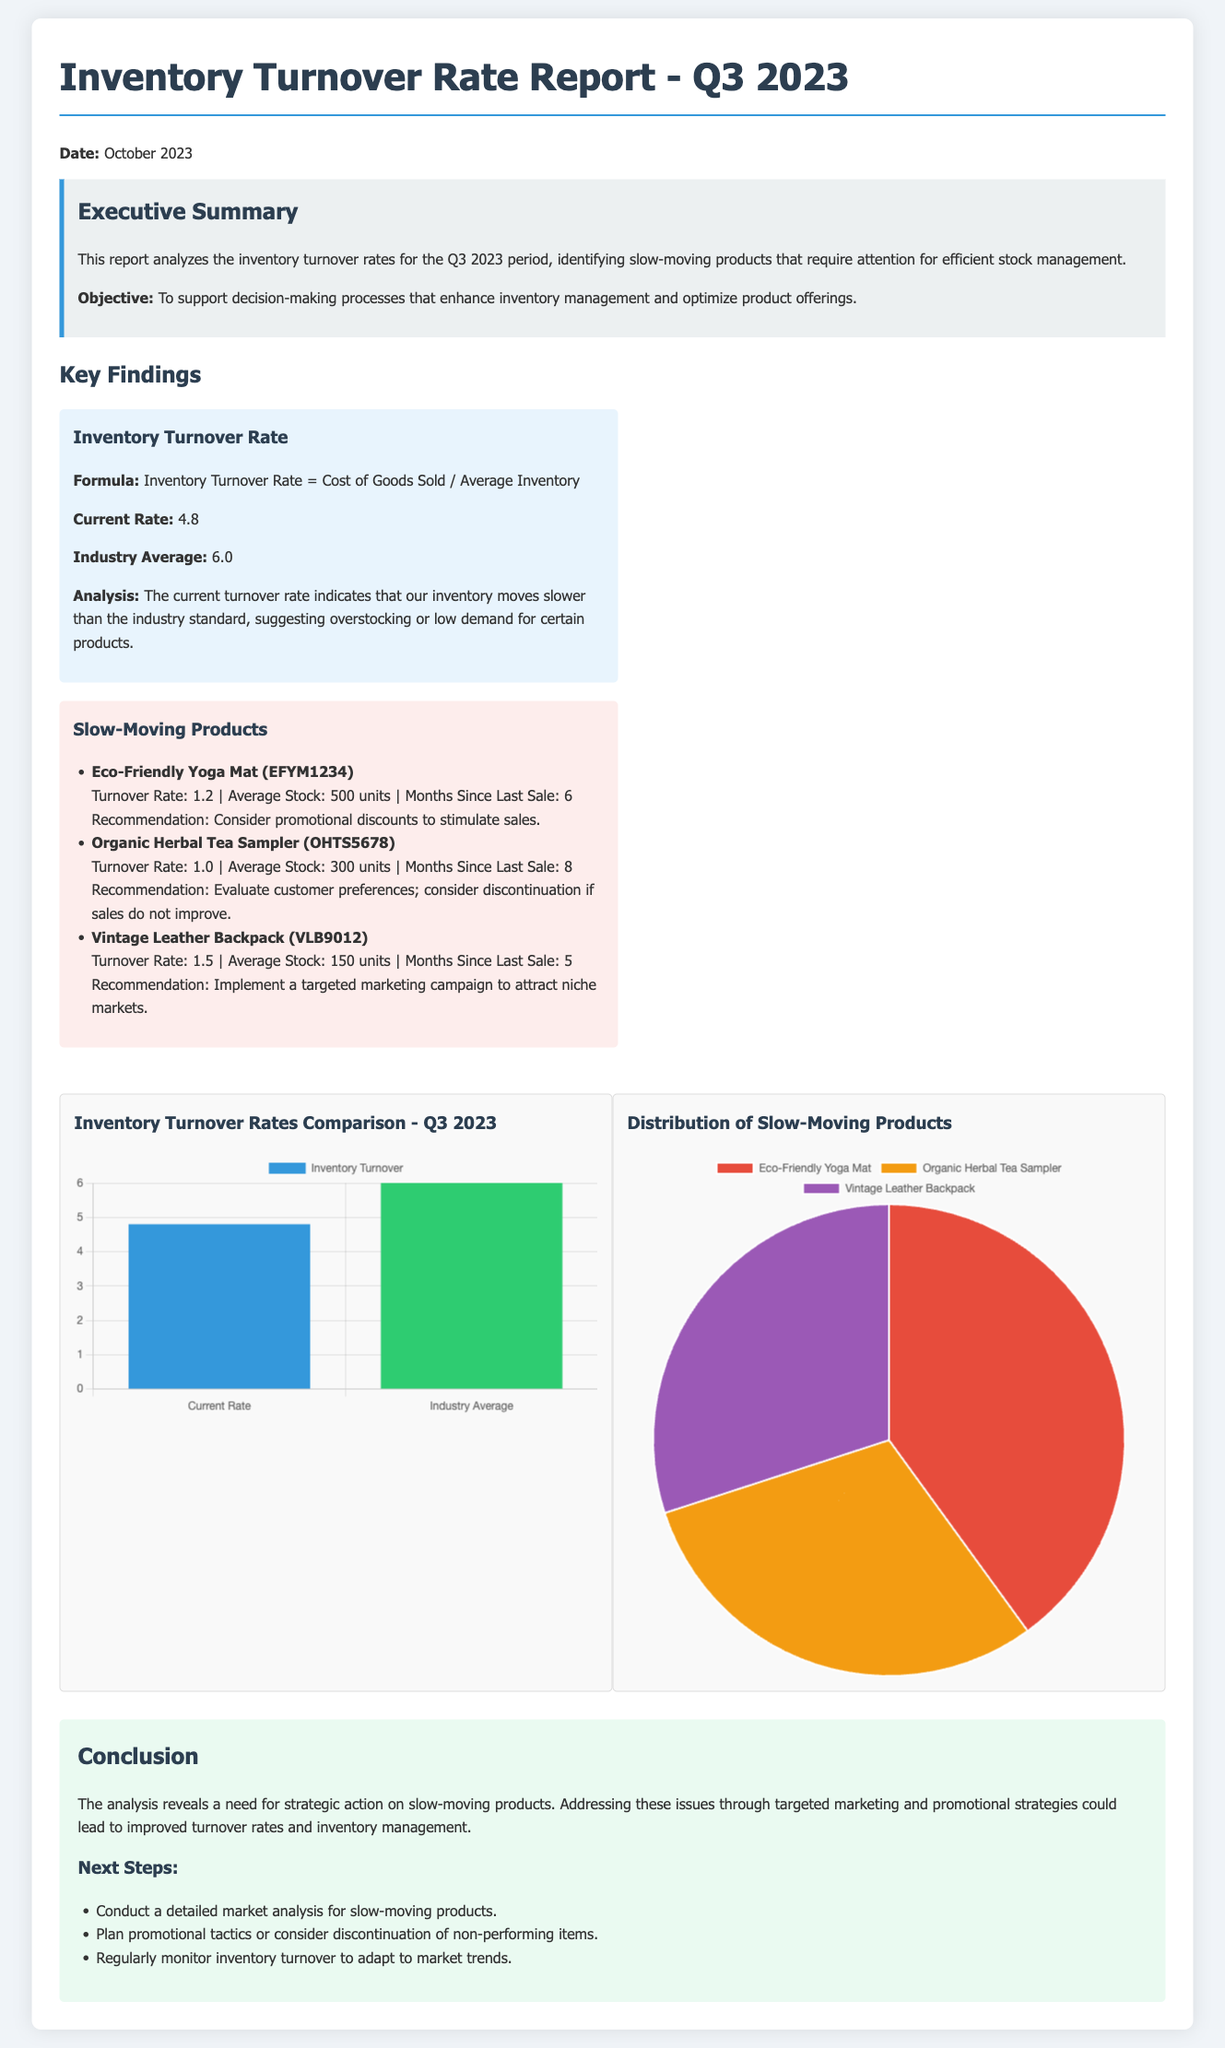What is the current inventory turnover rate? The current turnover rate is mentioned in the key findings section as part of the analysis.
Answer: 4.8 What is the industry average inventory turnover rate? The report states the industry average for comparison with the current rate in the key findings section.
Answer: 6.0 What is the turnover rate for the Eco-Friendly Yoga Mat? The slow-moving products section includes the turnover rate for this specific product.
Answer: 1.2 How many months has the Organic Herbal Tea Sampler been since its last sale? The detail for this product in the slow-moving section indicates how long it has remained unsold.
Answer: 8 What recommendation is given for the Vintage Leather Backpack? The recommended action for this product is listed in the slow-moving products section.
Answer: Implement a targeted marketing campaign to attract niche markets What type of visual aid is used to show the inventory turnover rates comparison? The document includes details about the type of chart used to illustrate the comparison of turnover rates.
Answer: Bar Chart What is the primary objective of this report? The executive summary outlines the main objective of the report, providing context for the analysis.
Answer: To support decision-making processes that enhance inventory management and optimize product offerings Which product has an average stock of 300 units? This detail for stock levels is mentioned alongside the product descriptions in the slow-moving section.
Answer: Organic Herbal Tea Sampler 